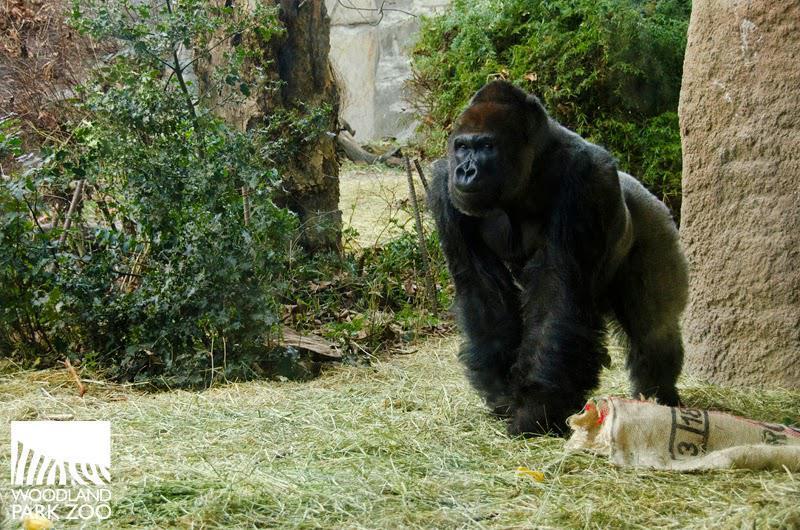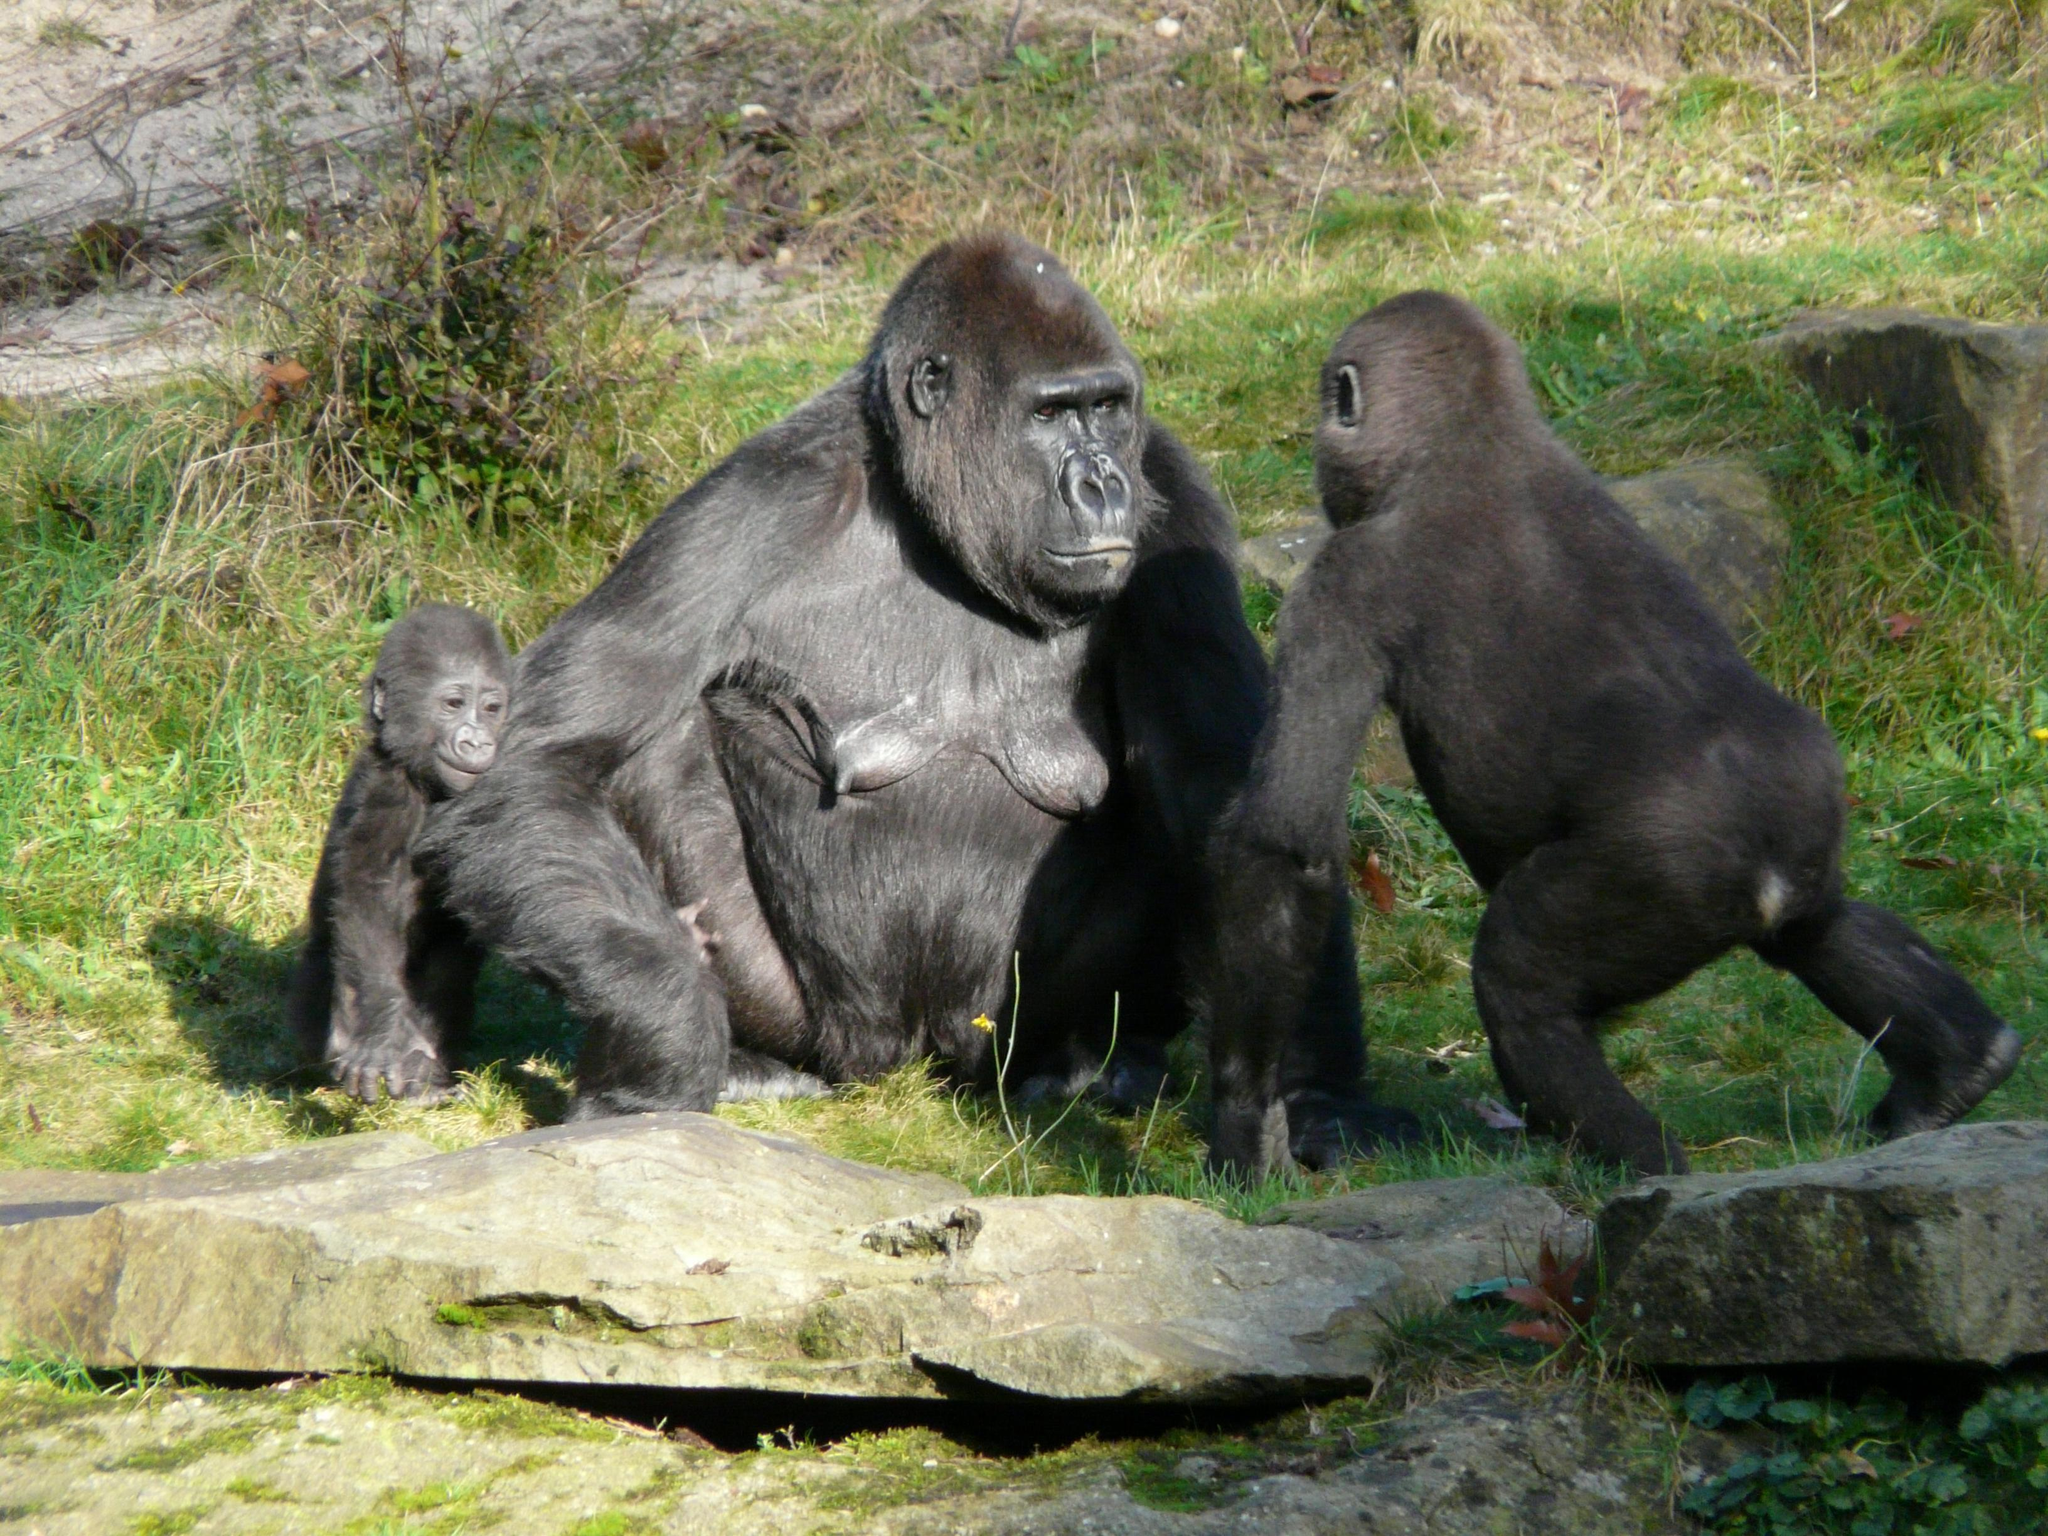The first image is the image on the left, the second image is the image on the right. For the images displayed, is the sentence "The left image contains a human interacting with a gorilla." factually correct? Answer yes or no. No. 